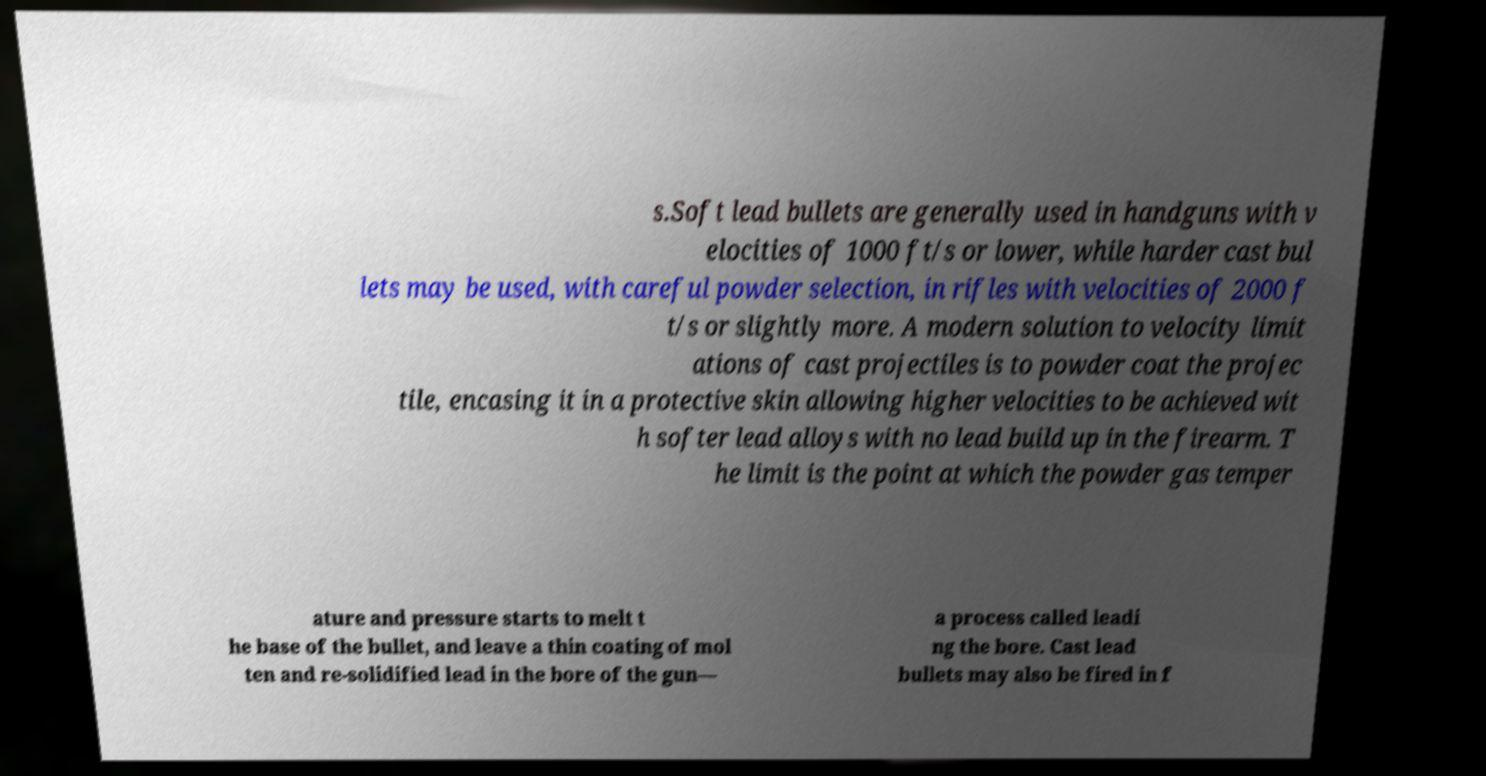Please read and relay the text visible in this image. What does it say? s.Soft lead bullets are generally used in handguns with v elocities of 1000 ft/s or lower, while harder cast bul lets may be used, with careful powder selection, in rifles with velocities of 2000 f t/s or slightly more. A modern solution to velocity limit ations of cast projectiles is to powder coat the projec tile, encasing it in a protective skin allowing higher velocities to be achieved wit h softer lead alloys with no lead build up in the firearm. T he limit is the point at which the powder gas temper ature and pressure starts to melt t he base of the bullet, and leave a thin coating of mol ten and re-solidified lead in the bore of the gun— a process called leadi ng the bore. Cast lead bullets may also be fired in f 